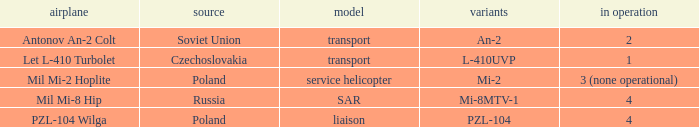Can you give me this table as a dict? {'header': ['airplane', 'source', 'model', 'variants', 'in operation'], 'rows': [['Antonov An-2 Colt', 'Soviet Union', 'transport', 'An-2', '2'], ['Let L-410 Turbolet', 'Czechoslovakia', 'transport', 'L-410UVP', '1'], ['Mil Mi-2 Hoplite', 'Poland', 'service helicopter', 'Mi-2', '3 (none operational)'], ['Mil Mi-8 Hip', 'Russia', 'SAR', 'Mi-8MTV-1', '4'], ['PZL-104 Wilga', 'Poland', 'liaison', 'PZL-104', '4']]} Tell me the aircraft for pzl-104 PZL-104 Wilga. 